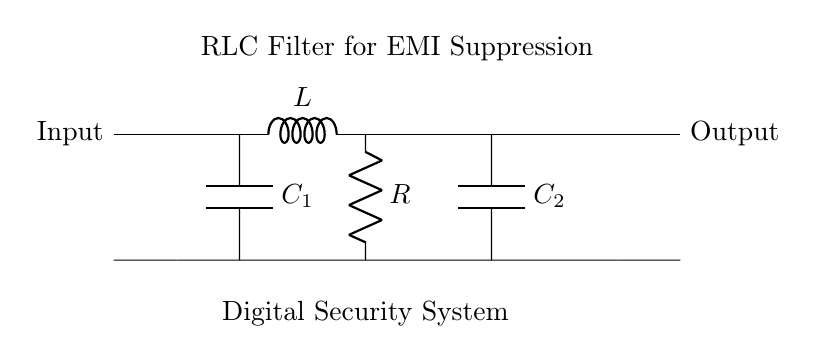What components are in this circuit? The circuit consists of an inductor (L), two capacitors (C1 and C2), and a resistor (R).
Answer: Inductor, Capacitors, Resistor What type of filter is this circuit? The circuit is an RLC filter, which combines resistance, inductance, and capacitance to filter signals.
Answer: RLC filter What is the purpose of this RLC filter? The purpose of the RLC filter is to suppress electromagnetic interference in digital security systems.
Answer: EMI suppression How many capacitors are used in this circuit? There are two capacitors identified in the circuit diagram, labeled C1 and C2.
Answer: Two capacitors What is the connection configuration of the components? The components are connected in a series-parallel configuration, with L in series and R, C1, and C2 in a parallel arrangement.
Answer: Series-parallel configuration What does R represent in this circuit? In the context of this circuit, R represents the resistance that helps control the current flow and filter out unwanted frequencies.
Answer: Resistance How do the capacitors (C1 and C2) affect the filtering characteristics? The capacitors, in conjunction with the inductor and resistor, determine the frequency response of the filter, allowing certain frequencies to pass while attenuating others.
Answer: Frequency response control 